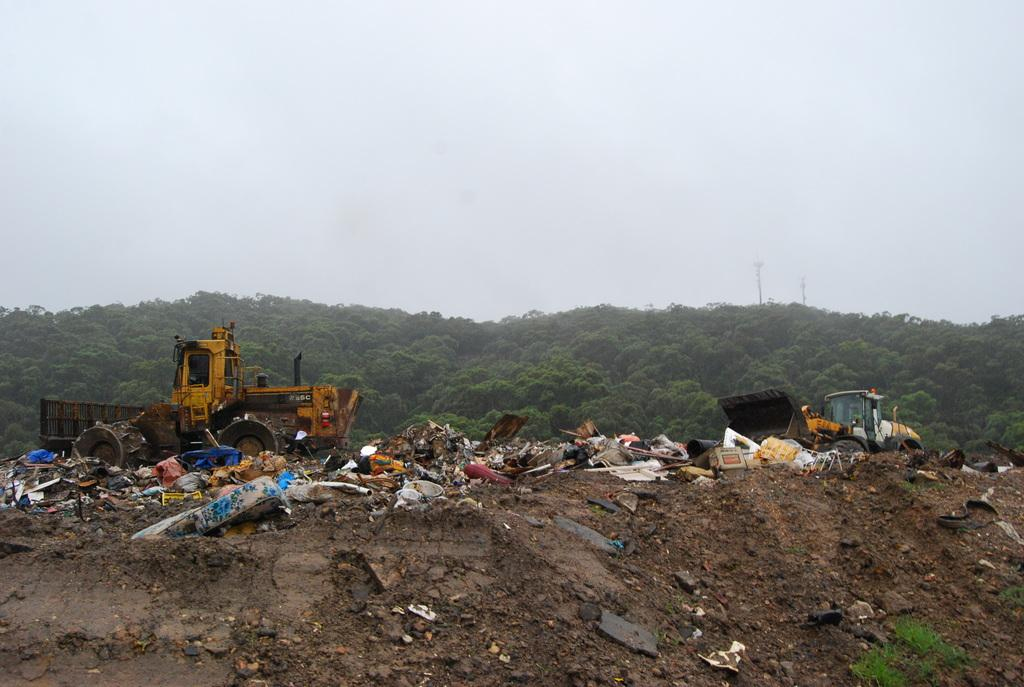What type of location is depicted in the image? There is a garbage yard in the image. What machinery can be seen in the image? There are two bulldozers in the image. What type of vegetation is visible in the background of the image? There are many trees in the background of the image. What is visible at the top of the image? The sky is visible at the top of the image. What type of shirt is the body of the bulldozer wearing in the image? There is no body or shirt present in the image, as the bulldozers are machines and not living beings. 